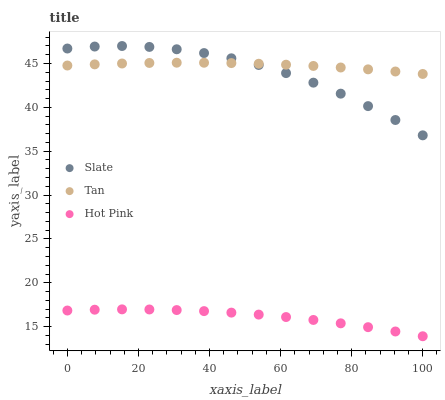Does Hot Pink have the minimum area under the curve?
Answer yes or no. Yes. Does Tan have the maximum area under the curve?
Answer yes or no. Yes. Does Tan have the minimum area under the curve?
Answer yes or no. No. Does Hot Pink have the maximum area under the curve?
Answer yes or no. No. Is Tan the smoothest?
Answer yes or no. Yes. Is Slate the roughest?
Answer yes or no. Yes. Is Hot Pink the smoothest?
Answer yes or no. No. Is Hot Pink the roughest?
Answer yes or no. No. Does Hot Pink have the lowest value?
Answer yes or no. Yes. Does Tan have the lowest value?
Answer yes or no. No. Does Slate have the highest value?
Answer yes or no. Yes. Does Tan have the highest value?
Answer yes or no. No. Is Hot Pink less than Tan?
Answer yes or no. Yes. Is Tan greater than Hot Pink?
Answer yes or no. Yes. Does Slate intersect Tan?
Answer yes or no. Yes. Is Slate less than Tan?
Answer yes or no. No. Is Slate greater than Tan?
Answer yes or no. No. Does Hot Pink intersect Tan?
Answer yes or no. No. 